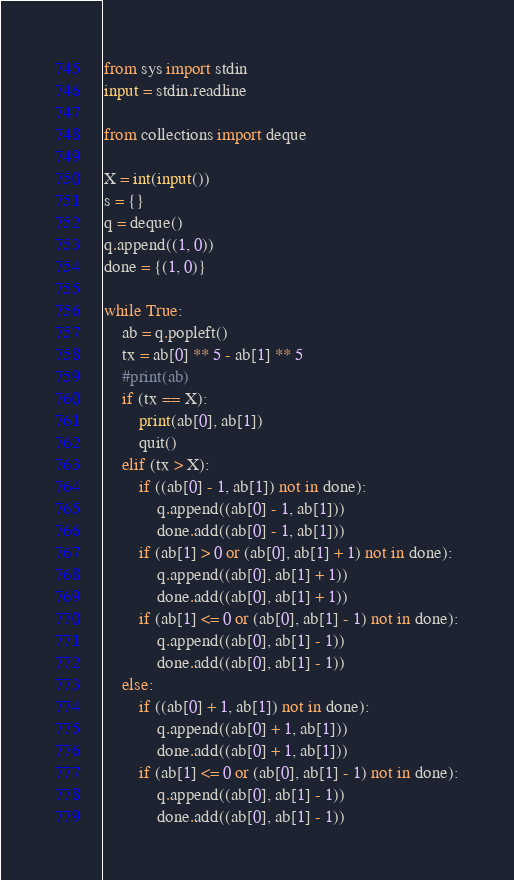Convert code to text. <code><loc_0><loc_0><loc_500><loc_500><_Python_>from sys import stdin
input = stdin.readline

from collections import deque

X = int(input())
s = {}
q = deque()
q.append((1, 0))
done = {(1, 0)}

while True:
	ab = q.popleft()
	tx = ab[0] ** 5 - ab[1] ** 5
	#print(ab)
	if (tx == X):
		print(ab[0], ab[1])
		quit()
	elif (tx > X):
		if ((ab[0] - 1, ab[1]) not in done):
			q.append((ab[0] - 1, ab[1]))
			done.add((ab[0] - 1, ab[1]))
		if (ab[1] > 0 or (ab[0], ab[1] + 1) not in done):
			q.append((ab[0], ab[1] + 1))
			done.add((ab[0], ab[1] + 1))
		if (ab[1] <= 0 or (ab[0], ab[1] - 1) not in done):
			q.append((ab[0], ab[1] - 1))
			done.add((ab[0], ab[1] - 1))
	else:
		if ((ab[0] + 1, ab[1]) not in done):
			q.append((ab[0] + 1, ab[1]))
			done.add((ab[0] + 1, ab[1]))
		if (ab[1] <= 0 or (ab[0], ab[1] - 1) not in done):
			q.append((ab[0], ab[1] - 1))
			done.add((ab[0], ab[1] - 1))
</code> 